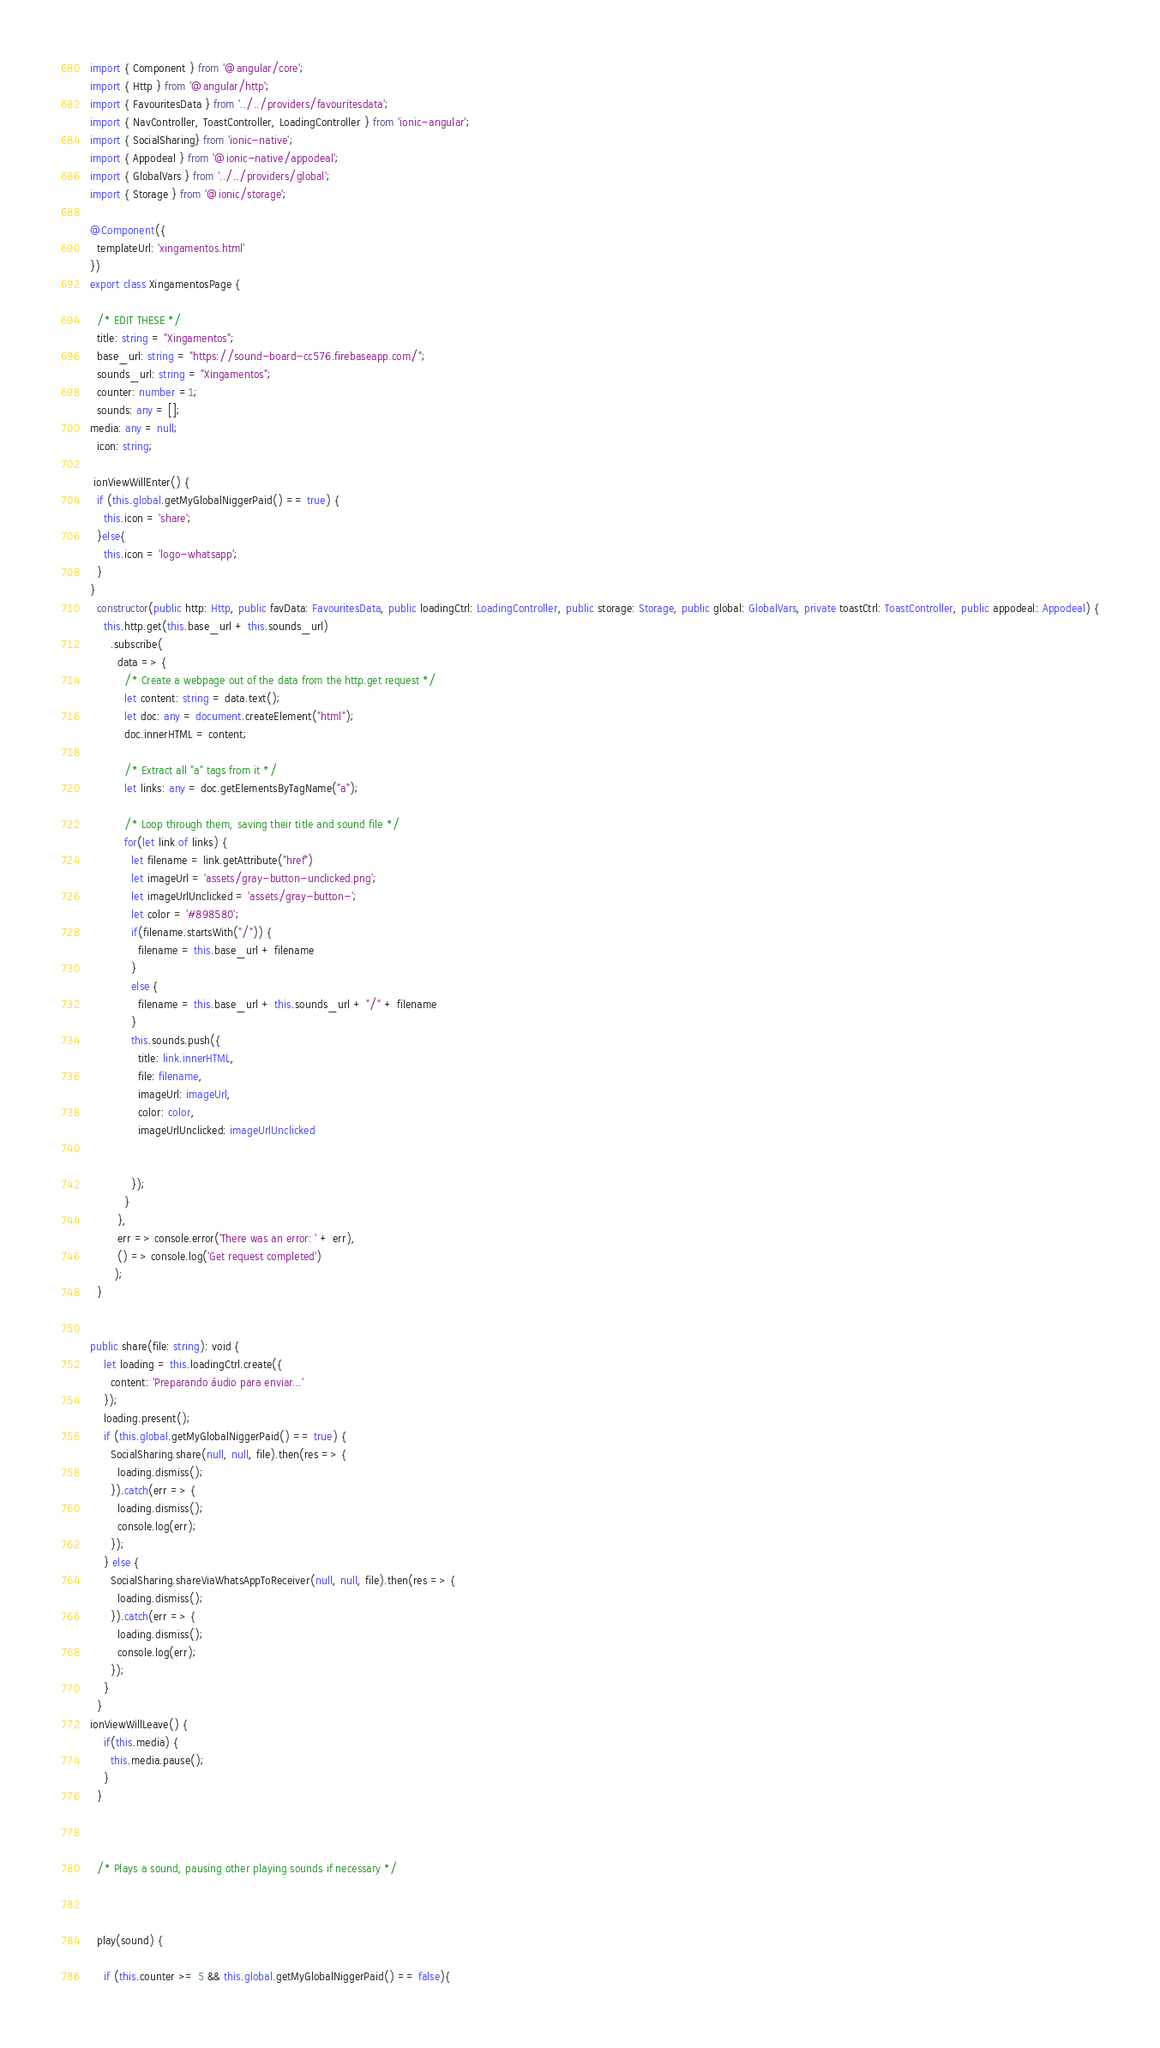<code> <loc_0><loc_0><loc_500><loc_500><_TypeScript_>import { Component } from '@angular/core';
import { Http } from '@angular/http';
import { FavouritesData } from '../../providers/favouritesdata';
import { NavController, ToastController, LoadingController } from 'ionic-angular';
import { SocialSharing} from 'ionic-native';
import { Appodeal } from '@ionic-native/appodeal';
import { GlobalVars } from '../../providers/global';
import { Storage } from '@ionic/storage';

@Component({
  templateUrl: 'xingamentos.html'
})
export class XingamentosPage {

  /* EDIT THESE */
  title: string = "Xingamentos";
  base_url: string = "https://sound-board-cc576.firebaseapp.com/";
  sounds_url: string = "Xingamentos";
  counter: number =1;  
  sounds: any = [];
media: any = null;
  icon: string;

 ionViewWillEnter() {    
  if (this.global.getMyGlobalNiggerPaid() == true) {
    this.icon = 'share';
  }else{
    this.icon = 'logo-whatsapp';
  }
}
  constructor(public http: Http, public favData: FavouritesData, public loadingCtrl: LoadingController, public storage: Storage, public global: GlobalVars, private toastCtrl: ToastController, public appodeal: Appodeal) {
    this.http.get(this.base_url + this.sounds_url)
      .subscribe(
        data => {
          /* Create a webpage out of the data from the http.get request */
          let content: string = data.text();
          let doc: any = document.createElement("html");
          doc.innerHTML = content;

          /* Extract all "a" tags from it */
          let links: any = doc.getElementsByTagName("a");

          /* Loop through them, saving their title and sound file */
          for(let link of links) {
            let filename = link.getAttribute("href")
            let imageUrl = 'assets/gray-button-unclicked.png';
            let imageUrlUnclicked = 'assets/gray-button-';            
            let color = '#898580';           
            if(filename.startsWith("/")) {
              filename = this.base_url + filename
            }
            else {
              filename = this.base_url + this.sounds_url + "/" + filename
            }
            this.sounds.push({
              title: link.innerHTML,
              file: filename,
              imageUrl: imageUrl,
              color: color,
              imageUrlUnclicked: imageUrlUnclicked
              

            });
          }
        },
        err => console.error('There was an error: ' + err),
        () => console.log('Get request completed')
       );
  }


public share(file: string): void {
    let loading = this.loadingCtrl.create({
      content: 'Preparando áudio para enviar...'
    });
    loading.present();
    if (this.global.getMyGlobalNiggerPaid() == true) {
      SocialSharing.share(null, null, file).then(res => {
        loading.dismiss();
      }).catch(err => {
        loading.dismiss();
        console.log(err);
      });
    } else {
      SocialSharing.shareViaWhatsAppToReceiver(null, null, file).then(res => {
        loading.dismiss();
      }).catch(err => {
        loading.dismiss();
        console.log(err);
      });
    }   
  }
ionViewWillLeave() {
    if(this.media) {
      this.media.pause();
    }
  }
 


  /* Plays a sound, pausing other playing sounds if necessary */

  
  
  play(sound) { 
   
    if (this.counter >= 5 && this.global.getMyGlobalNiggerPaid() == false){  </code> 